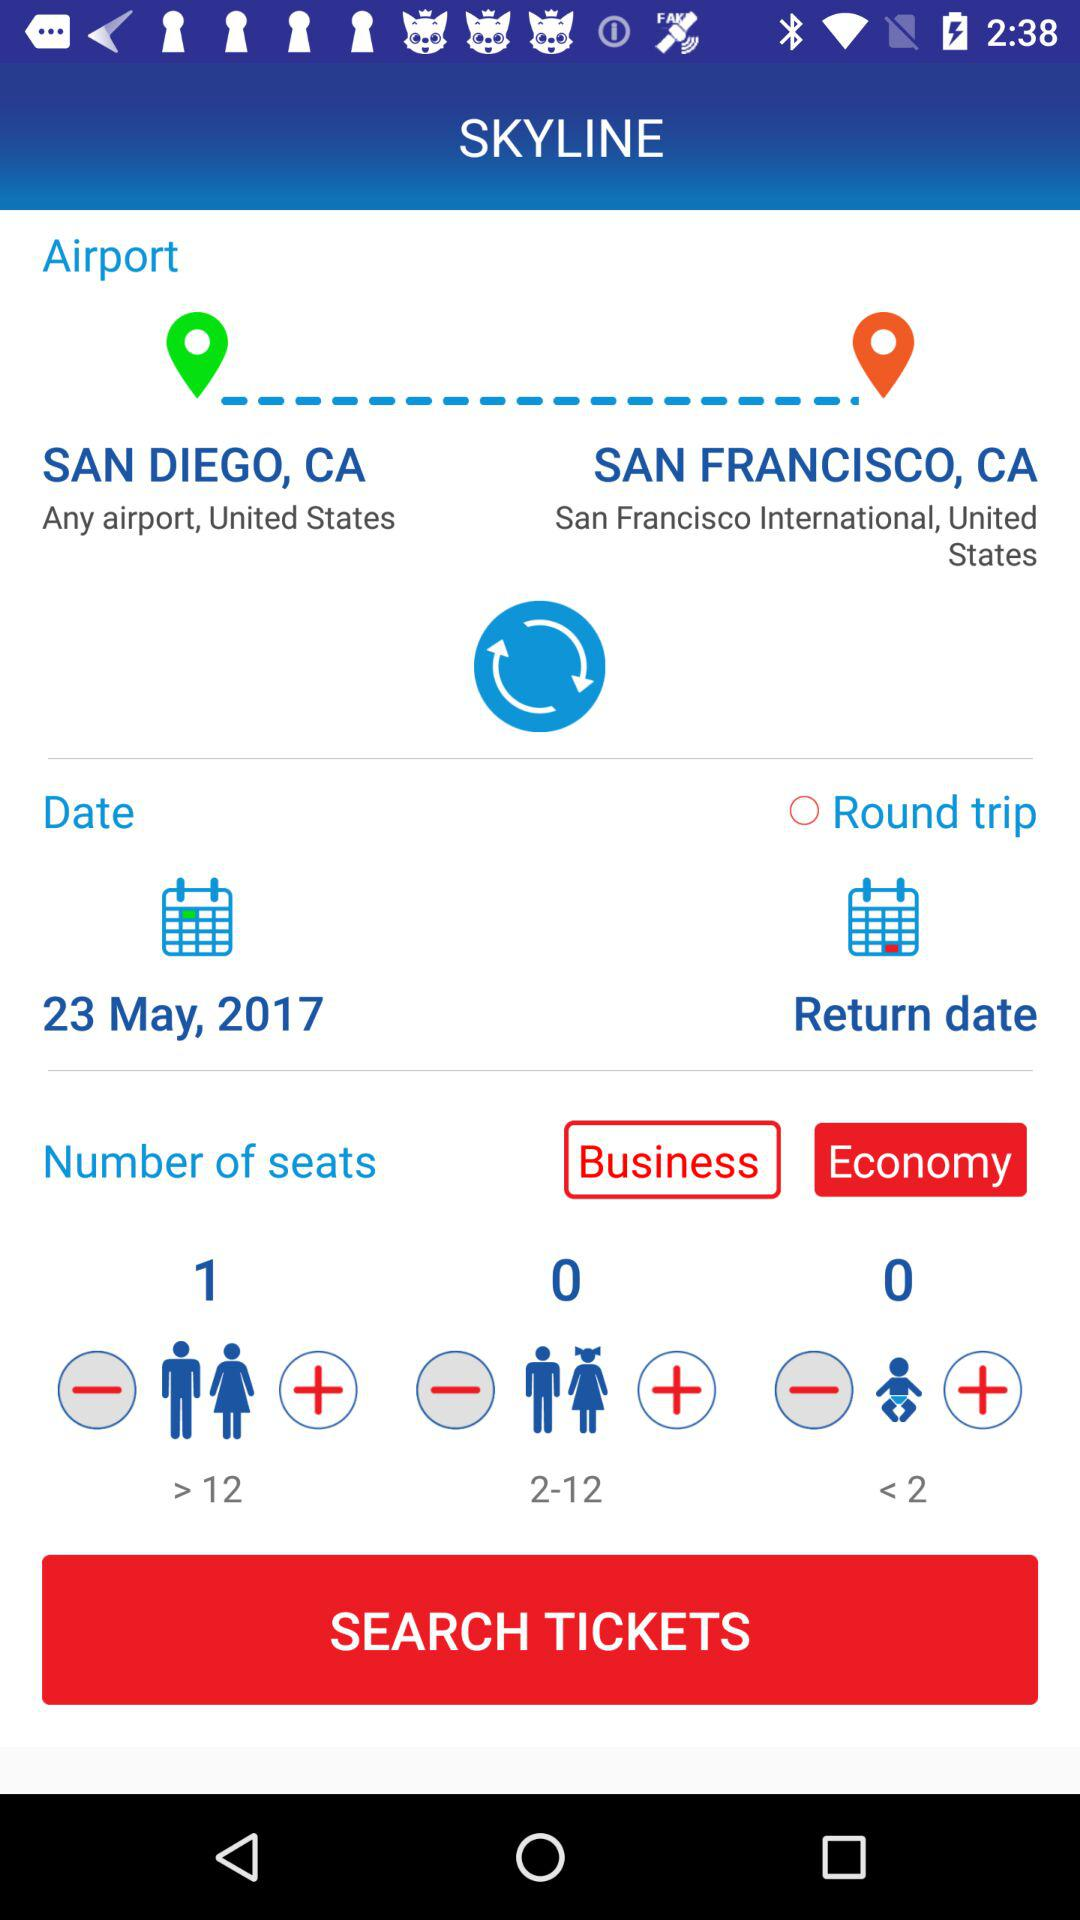How many seats are selected for "> 12"? There is one selected seat. 